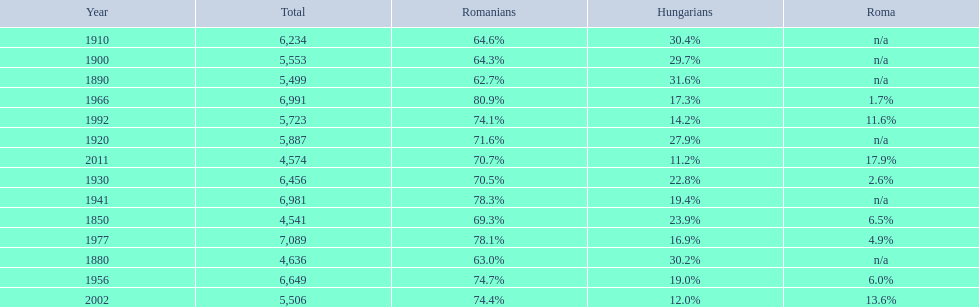What is the number of hungarians in 1850? 23.9%. 